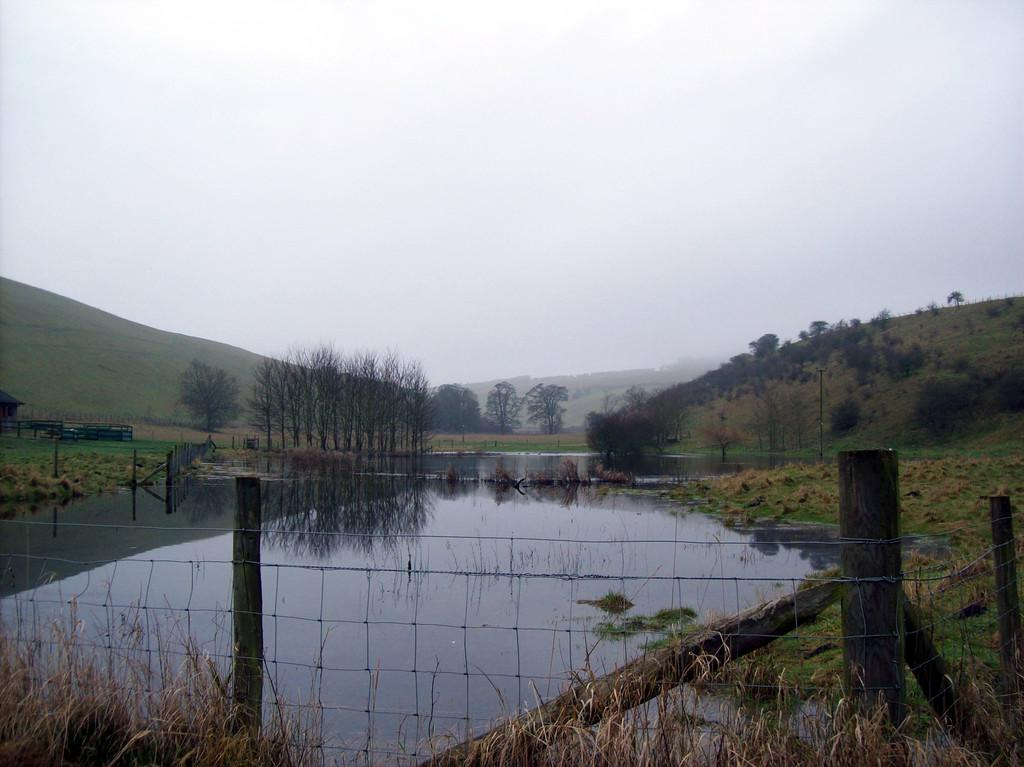What is the primary element visible in the image? There is water in the image. What type of structure can be seen in the image? There is a fence in the image. What are the poles used for in the image? The poles are likely used to support the fence or other structures. What type of vegetation is visible in the image? There is grass and trees visible in the image. What type of landscape feature can be seen in the image? There are hills in the image. What is visible in the sky in the image? The sky is visible in the image. What type of dress is the water wearing in the image? The water is not wearing a dress, as it is a natural element and not a person or object that can wear clothing. 